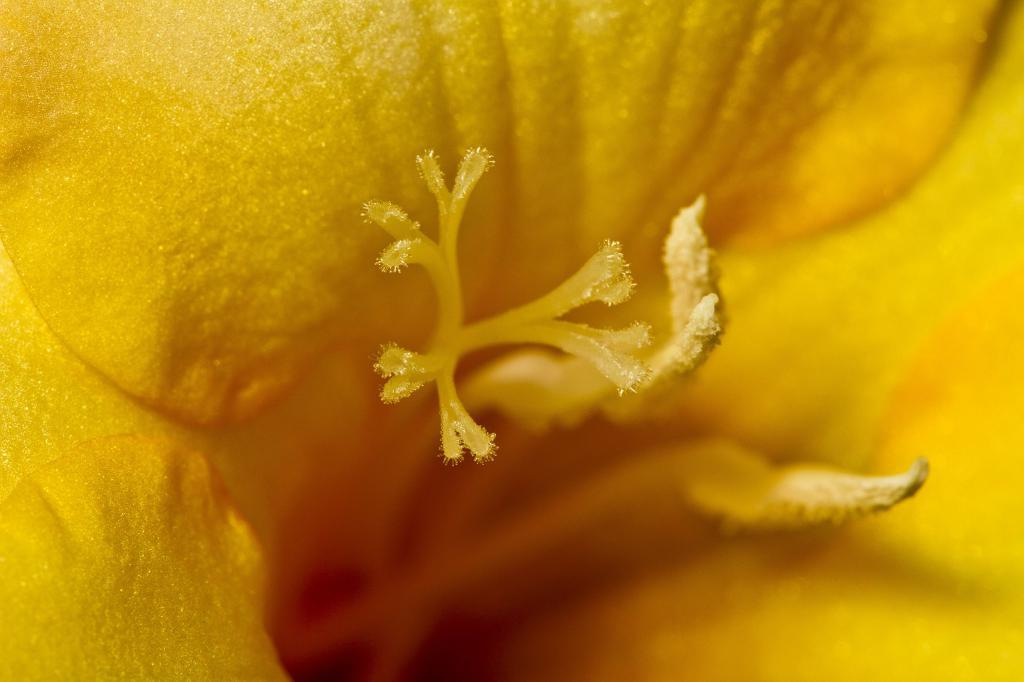What color is the flower in the image? The flower in the image is yellow. What are the main parts of the flower that can be seen? The flower has an anther and a stigma. Are there any other visible elements on the flower? Yes, pollen grains are visible on the flower. What type of mailbox is located near the flower in the image? There is no mailbox present in the image; it only features a yellow flower with an anther, stigma, and pollen grains. 